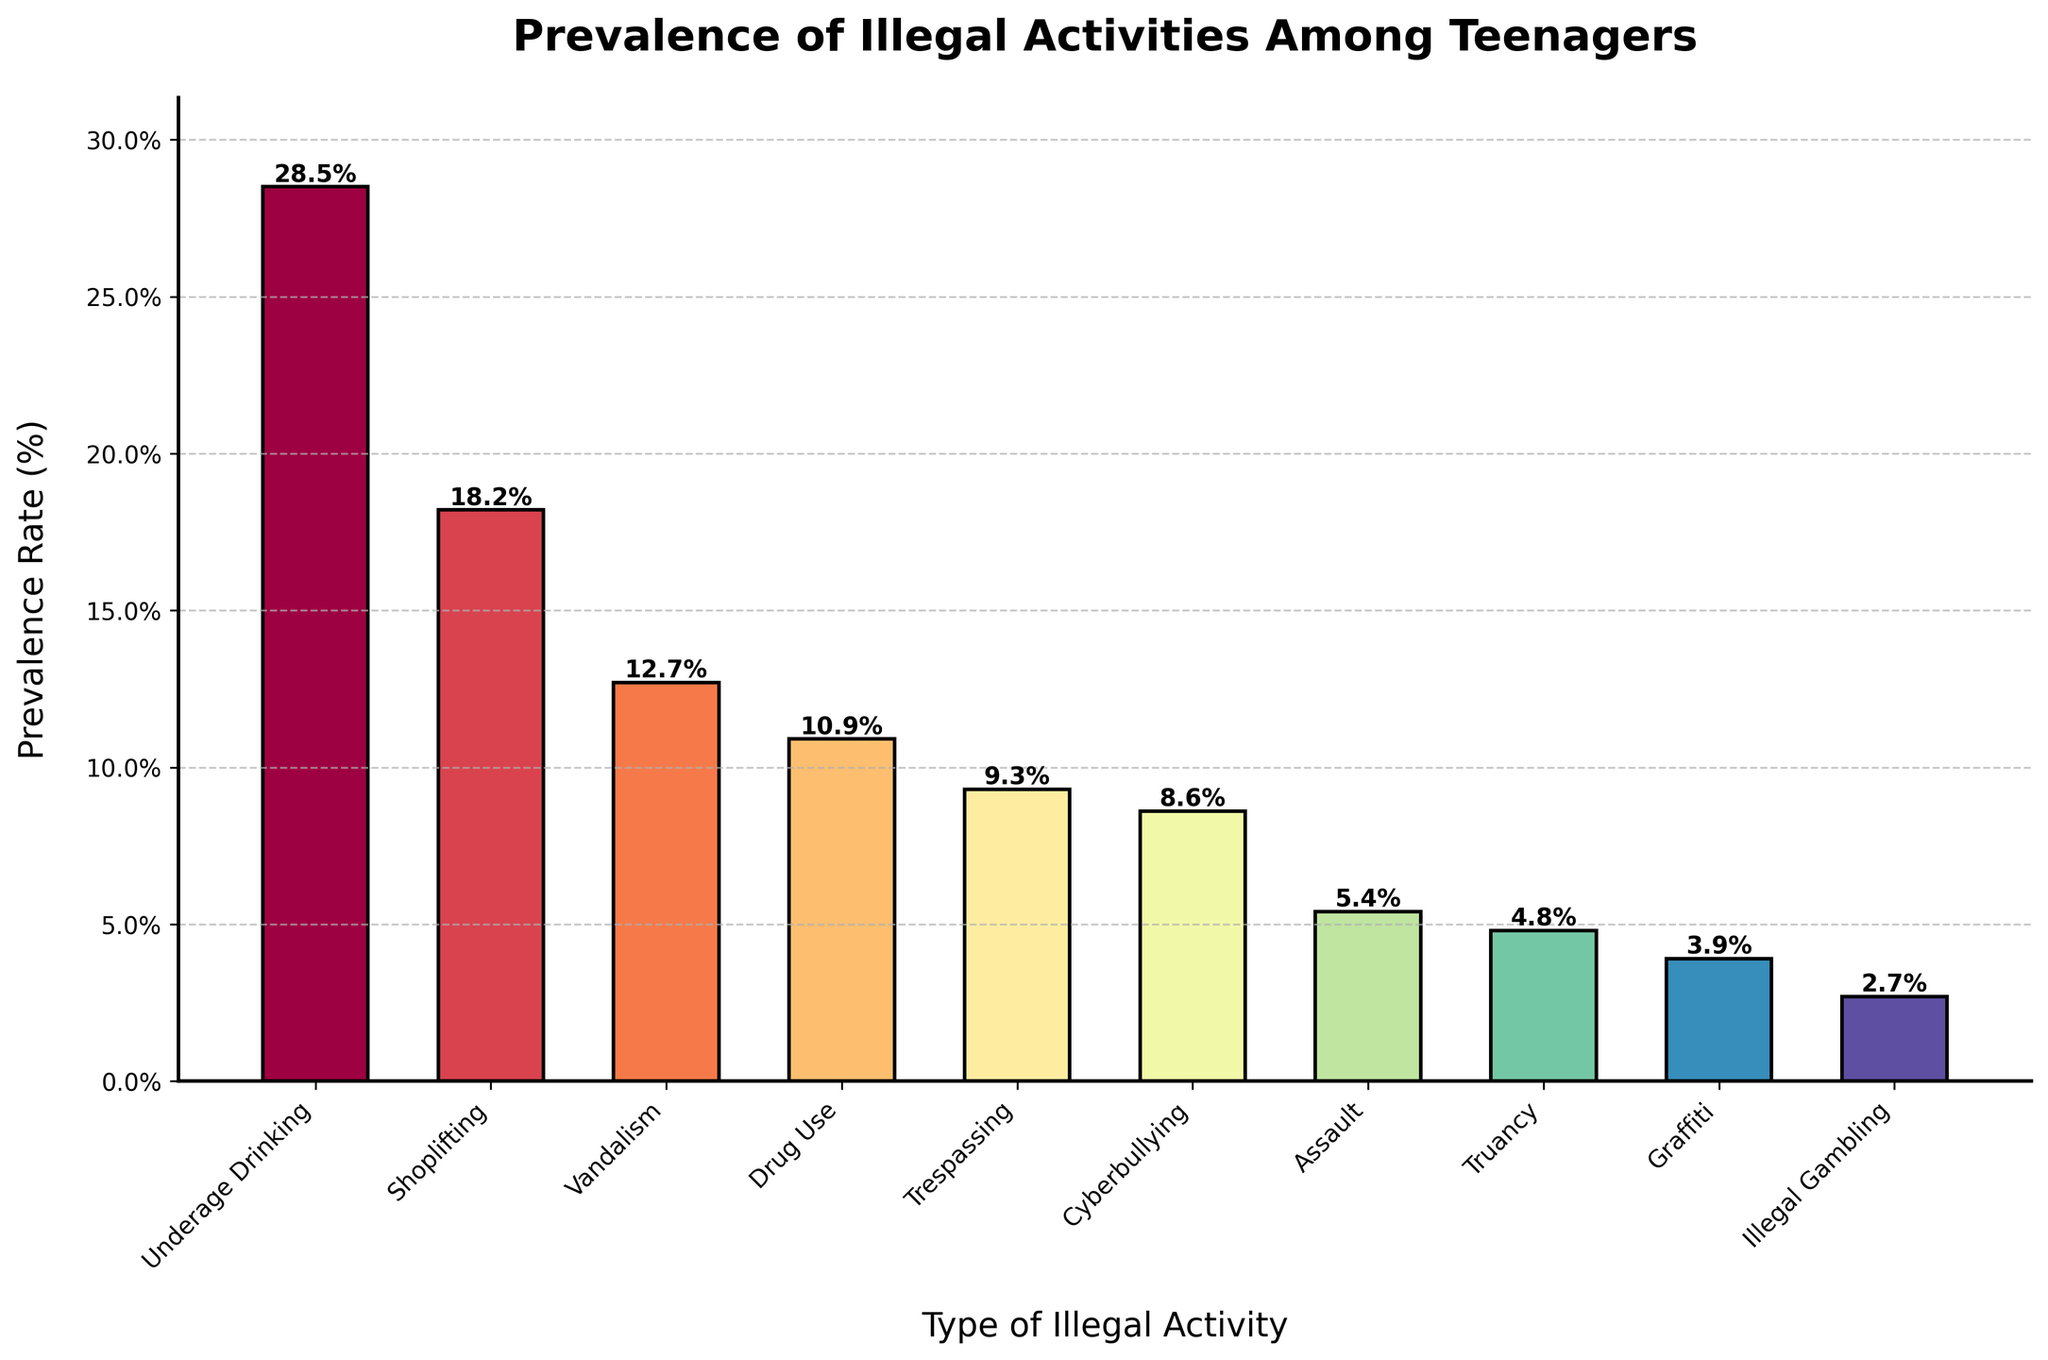What is the most prevalent illegal activity among teenagers? The highest bar in the chart represents the most prevalent activity. Underage Drinking has the highest bar at 28.5%.
Answer: Underage Drinking Which illegal activity has the lowest prevalence rate among teenagers? The shortest bar in the chart represents the lowest prevalence rate. Illegal Gambling has the shortest bar at 2.7%.
Answer: Illegal Gambling How much higher is the prevalence rate of Underage Drinking compared to Illegal Gambling? Subtract the prevalence rate of Illegal Gambling from the prevalence rate of Underage Drinking: 28.5% - 2.7% = 25.8%.
Answer: 25.8% Which two illegal activities have a prevalence rate above 10% but below 20%? The bars between 10% and 20% are Shoplifting (18.2%) and Vandalism (12.7%).
Answer: Shoplifting and Vandalism What is the combined prevalence rate of Cyberbullying and Assault? Add the prevalence rates of Cyberbullying (8.6%) and Assault (5.4%): 8.6% + 5.4% = 14%.
Answer: 14% Is Drug Use more prevalent than Trespassing? Compare the bars for Drug Use (10.9%) and Trespassing (9.3%). Drug Use has a higher bar.
Answer: Yes Between which two illegal activities is there the smallest difference in prevalence rates? Calculate the differences: Cyberbullying (8.6%) - Trespassing (9.3%) = 0.7%. This is the smallest difference.
Answer: Cyberbullying and Trespassing What is the average prevalence rate of the top three illegal activities? Add the prevalence rates of Underage Drinking (28.5%), Shoplifting (18.2%), and Vandalism (12.7%) and divide by 3: (28.5% + 18.2% + 12.7%) / 3 = 19.8%.
Answer: 19.8% Which activities have a prevalence rate below 5%? The bars below 5% are Truancy (4.8%), Graffiti (3.9%), and Illegal Gambling (2.7%).
Answer: Truancy, Graffiti, and Illegal Gambling How many illegal activities have a prevalence rate between 5% and 15%? Count the bars between 5% and 15%. There are Vandalism (12.7%), Drug Use (10.9%), Trespassing (9.3%), and Cyberbullying (8.6%).
Answer: Four 